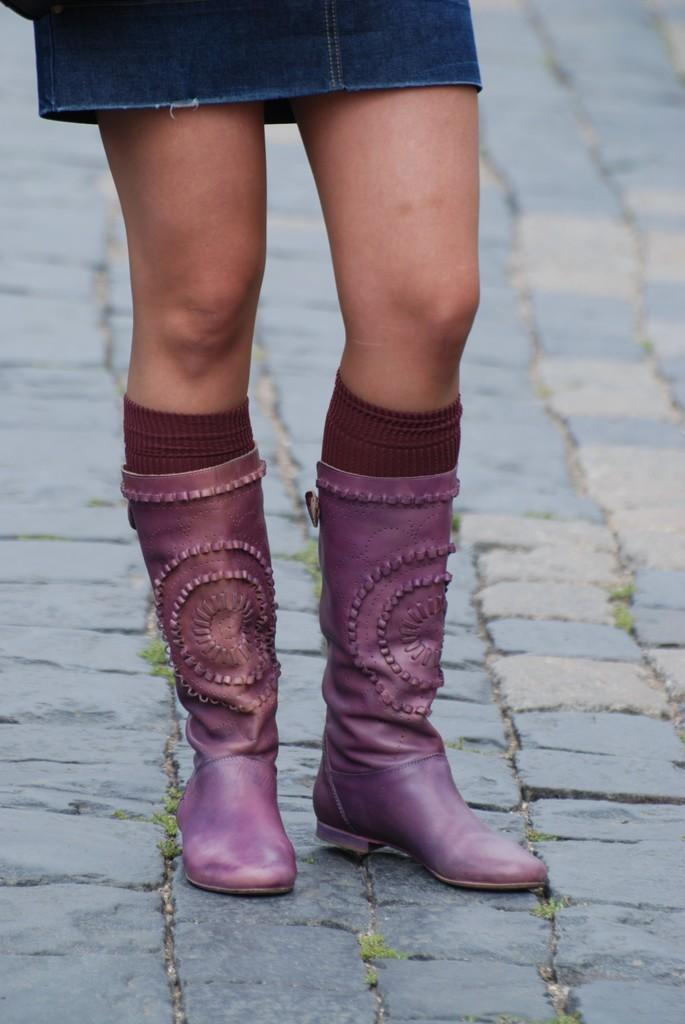What is the main subject of the image? There is a person in the image. What part of the person's body is visible in the center of the image? The person's legs are visible in the center of the image. What type of clothing is the person wearing on their lower body? The person is wearing a skirt. What type of footwear is the person wearing? The person is wearing shoes. What type of socks is the person wearing? The person is wearing socks. What can be seen in the background of the image? There is a floor and grass visible in the background of the image. What type of stitch is used to hold the grass together in the image? There is no stitching involved in the grass; it is a natural plant. What is the mass of the person in the image? It is not possible to determine the mass of the person from the image alone. 